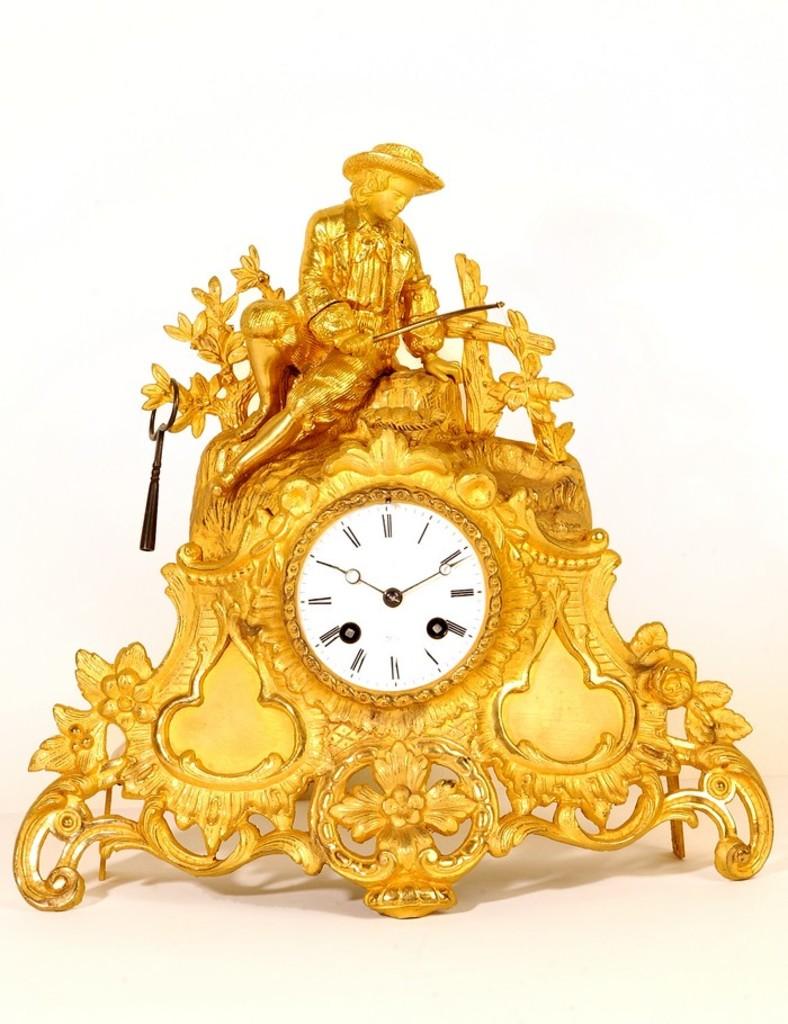What number is the big hand on?
Ensure brevity in your answer.  2. 